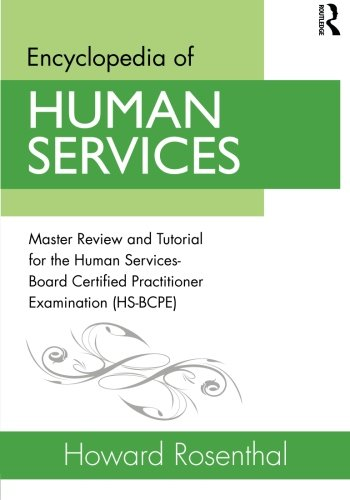Who wrote this book? The author of the book is Howard Rosenthal, who is known for his contributions to the field of human services and for preparing practitioners for certification exams. 